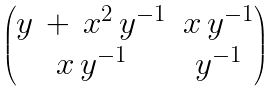Convert formula to latex. <formula><loc_0><loc_0><loc_500><loc_500>\begin{pmatrix} y \, + \, x ^ { 2 } \, y ^ { - 1 } & x \, y ^ { - 1 } \\ x \, y ^ { - 1 } & y ^ { - 1 } \end{pmatrix}</formula> 